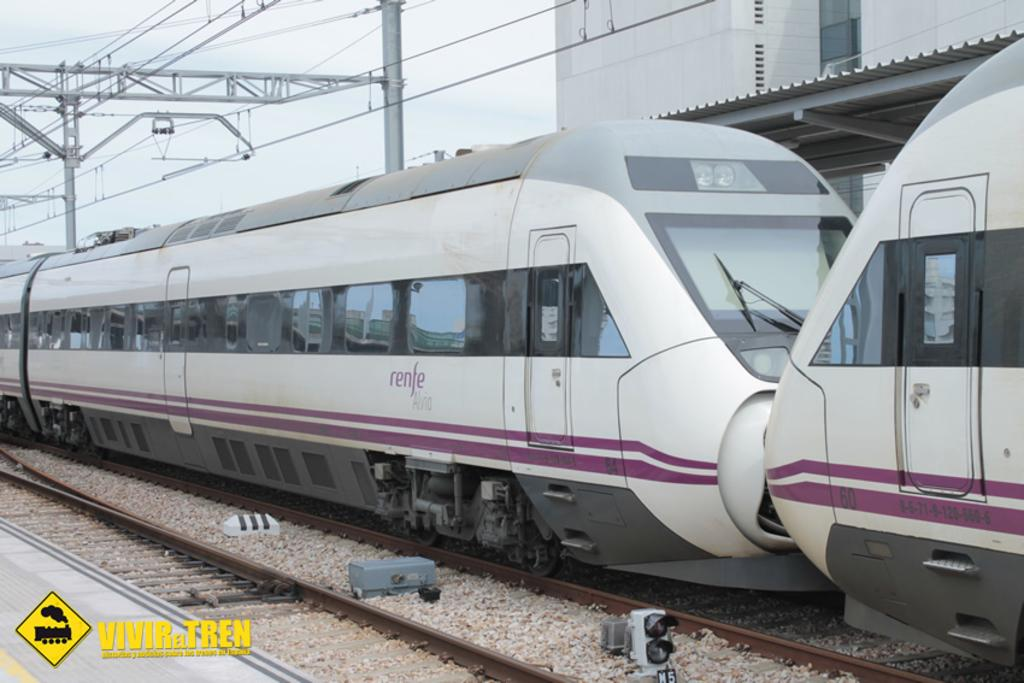<image>
Write a terse but informative summary of the picture. A pink train with the word renfe printed on the side 